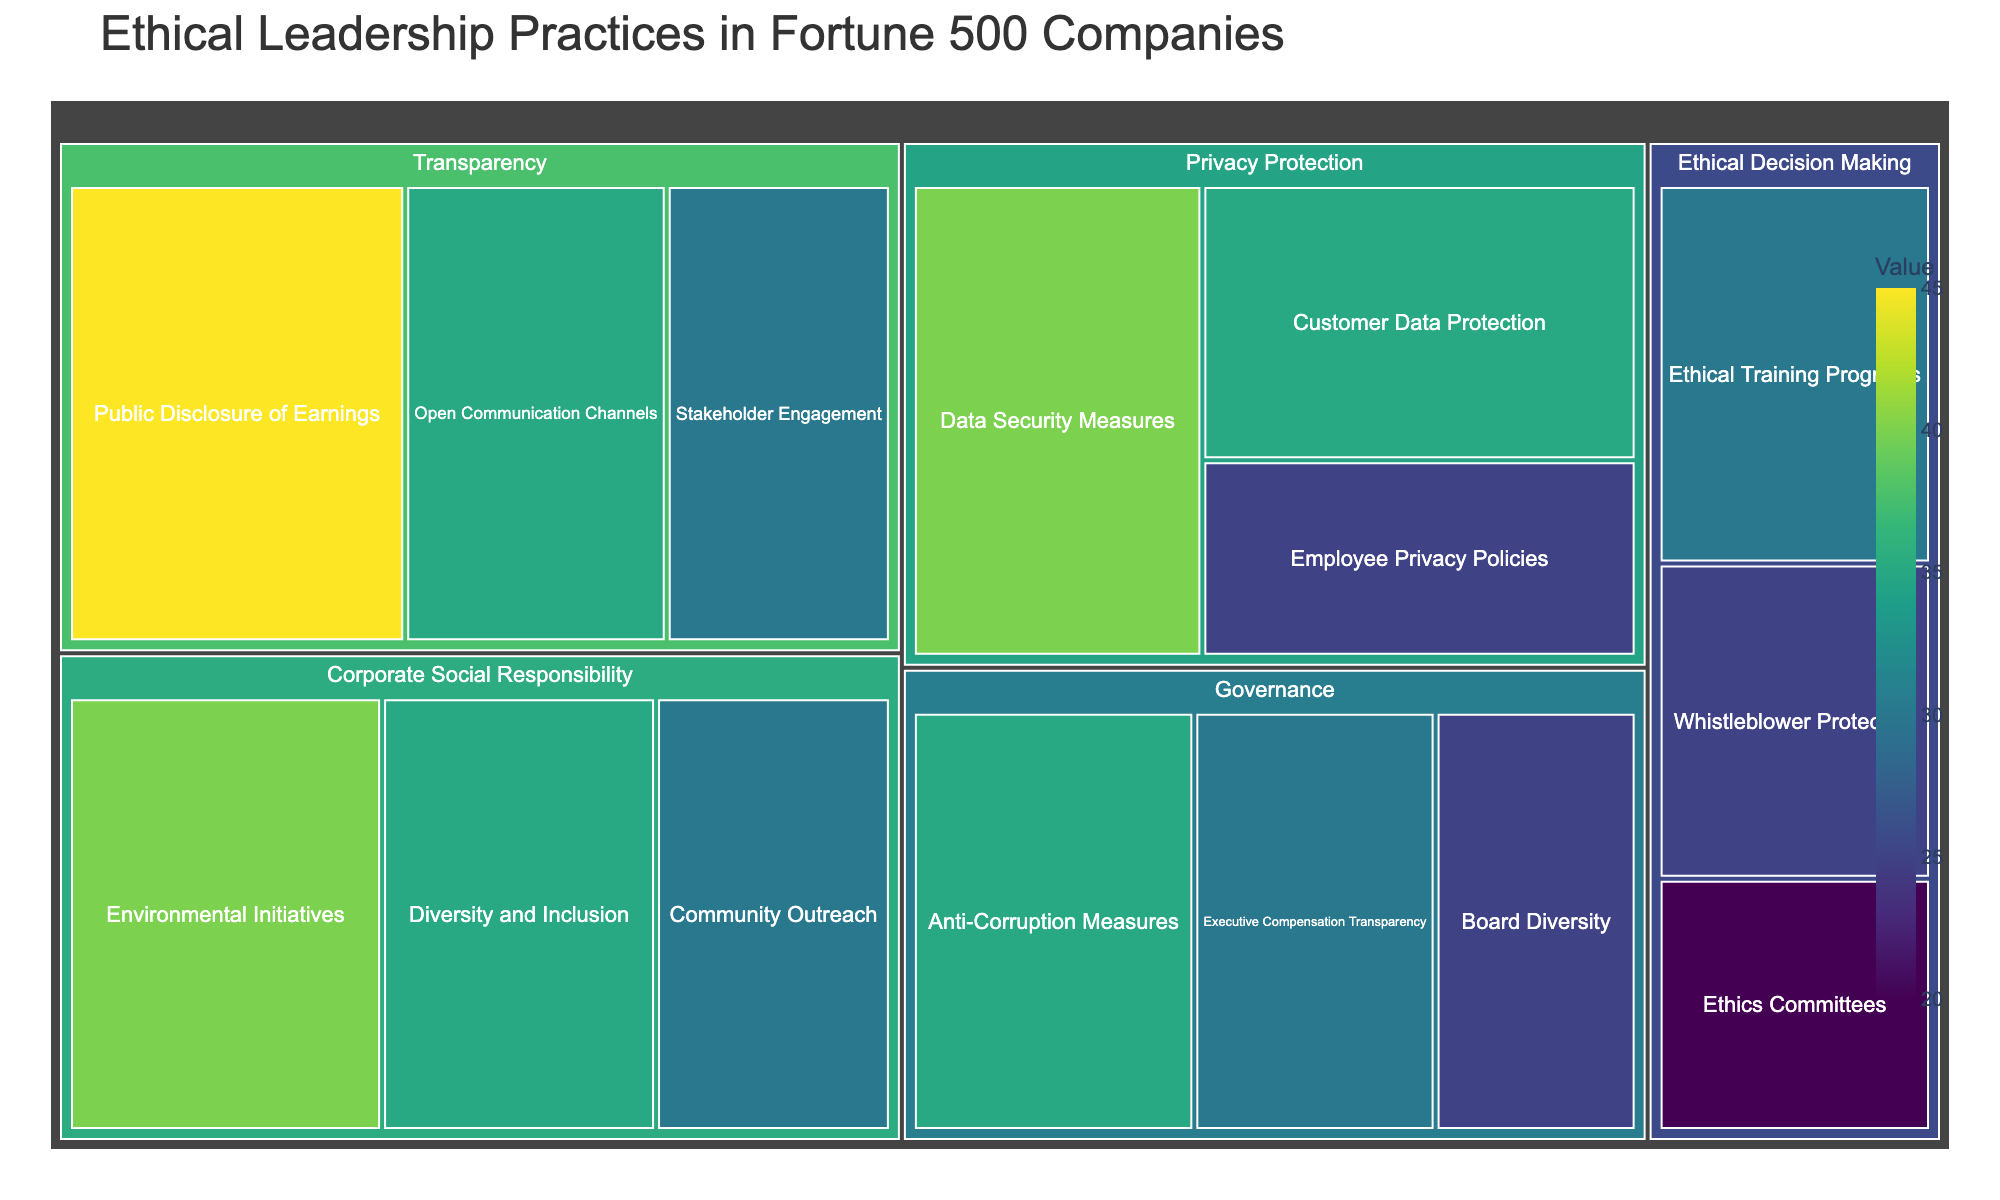Which category has the highest value in the treemap? We look at all the categories (Transparency, Privacy Protection, Ethical Decision Making, Corporate Social Responsibility, and Governance), and sum up their subcategory values. Corporate Social Responsibility has the highest total value of 105.
Answer: Corporate Social Responsibility What is the combined value of all subcategories under Transparency? We add the values of all subcategories under Transparency: (Public Disclosure of Earnings 45 + Open Communication Channels 35 + Stakeholder Engagement 30). The combined value is 110.
Answer: 110 Between the subcategories "Ethical Training Programs" and "Environmental Initiatives", which has a higher value and by how much? The value for Ethical Training Programs is 30 and for Environmental Initiatives is 40. The difference in their values is 40 - 30 = 10.
Answer: Environmental Initiatives by 10 What is the total number of subcategories in the treemap? We count all unique labels within each category of the treemap. There are 15 subcategories in total.
Answer: 15 What percentage of the total value does the category "Governance" represent? First, sum the values of all subcategories to get the total value, which is 420. Then, sum the values for Governance (Board Diversity 25 + Executive Compensation Transparency 30 + Anti-Corruption Measures 35) which totals 90. The percentage is (90 / 420) * 100.
Answer: 21.43% Which subcategory has the smallest value and what is it? By reviewing the values of all subcategories, we can see that the subcategory "Ethics Committees" has the smallest value, which is 20.
Answer: Ethics Committees, 20 How does the value of "Customer Data Protection" compare to "Employee Privacy Policies"? The value for Customer Data Protection is 35 and Employee Privacy Policies is 25. Customer Data Protection is 10 units higher compared to Employee Privacy Policies.
Answer: Customer Data Protection is higher by 10 Is the value of "Diversity and Inclusion" more than "Whistleblower Protection"? If yes, by how much? The value of Diversity and Inclusion is 35, while Whistleblower Protection is 25. The difference is 35 - 25 = 10.
Answer: Yes, by 10 What's the average value of subcategories under "Privacy Protection"? We add the values of subcategories under Privacy Protection (Data Security Measures 40 + Employee Privacy Policies 25 + Customer Data Protection 35) and divide by the number of subcategories (3). The average value is (40 + 25 + 35) / 3 = 33.33.
Answer: 33.33 